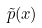Convert formula to latex. <formula><loc_0><loc_0><loc_500><loc_500>\tilde { p } ( x )</formula> 